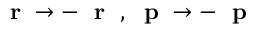<formula> <loc_0><loc_0><loc_500><loc_500>r \to - r \, , p \to - p</formula> 